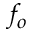Convert formula to latex. <formula><loc_0><loc_0><loc_500><loc_500>f _ { o }</formula> 